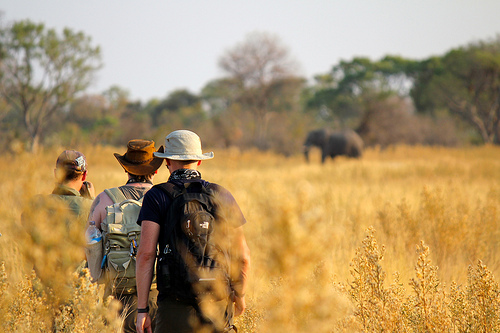Is there any hat that is blue? No, there is no hat that is blue. 